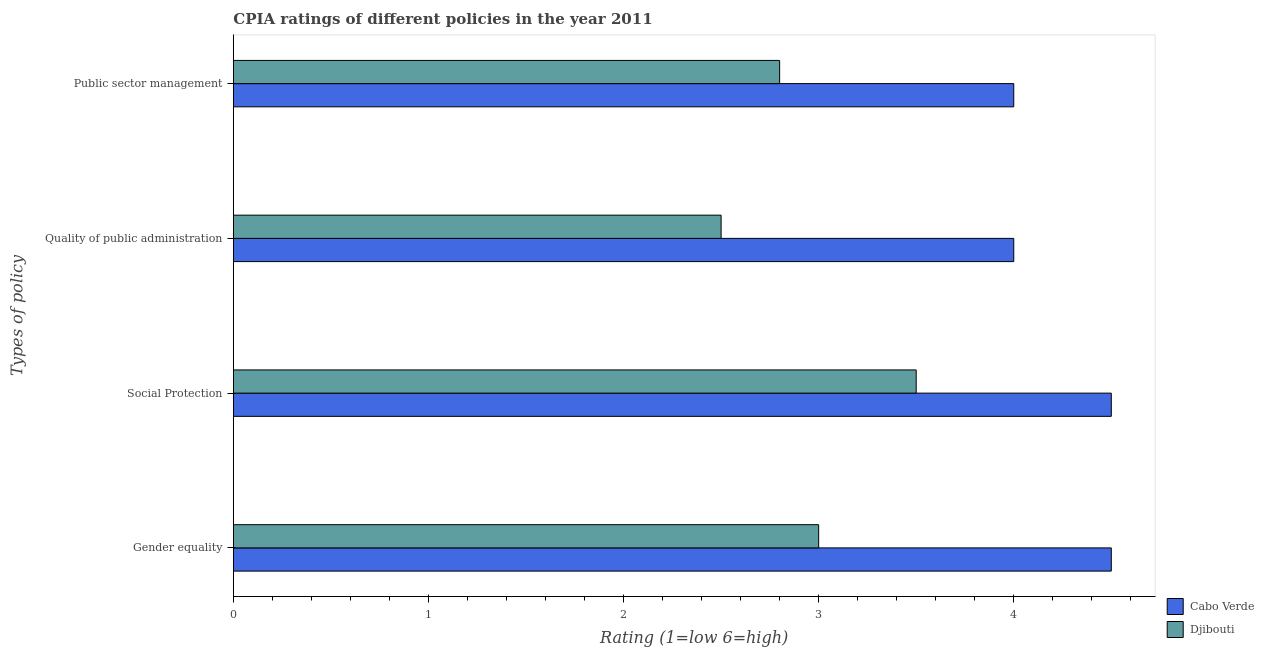How many different coloured bars are there?
Offer a terse response. 2. How many groups of bars are there?
Offer a very short reply. 4. How many bars are there on the 3rd tick from the top?
Your response must be concise. 2. What is the label of the 4th group of bars from the top?
Ensure brevity in your answer.  Gender equality. What is the cpia rating of quality of public administration in Cabo Verde?
Provide a succinct answer. 4. In which country was the cpia rating of quality of public administration maximum?
Your response must be concise. Cabo Verde. In which country was the cpia rating of gender equality minimum?
Offer a terse response. Djibouti. What is the total cpia rating of public sector management in the graph?
Provide a succinct answer. 6.8. What is the difference between the cpia rating of quality of public administration in Cabo Verde and that in Djibouti?
Provide a short and direct response. 1.5. What is the difference between the cpia rating of social protection in Cabo Verde and the cpia rating of gender equality in Djibouti?
Your answer should be compact. 1.5. What is the average cpia rating of quality of public administration per country?
Offer a very short reply. 3.25. What is the difference between the cpia rating of quality of public administration and cpia rating of public sector management in Djibouti?
Provide a short and direct response. -0.3. In how many countries, is the cpia rating of gender equality greater than 0.4 ?
Provide a short and direct response. 2. What is the ratio of the cpia rating of gender equality in Djibouti to that in Cabo Verde?
Keep it short and to the point. 0.67. What is the difference between the highest and the lowest cpia rating of gender equality?
Your answer should be very brief. 1.5. In how many countries, is the cpia rating of quality of public administration greater than the average cpia rating of quality of public administration taken over all countries?
Your response must be concise. 1. Is the sum of the cpia rating of gender equality in Cabo Verde and Djibouti greater than the maximum cpia rating of social protection across all countries?
Make the answer very short. Yes. Is it the case that in every country, the sum of the cpia rating of public sector management and cpia rating of gender equality is greater than the sum of cpia rating of social protection and cpia rating of quality of public administration?
Provide a succinct answer. No. What does the 2nd bar from the top in Public sector management represents?
Ensure brevity in your answer.  Cabo Verde. What does the 1st bar from the bottom in Gender equality represents?
Make the answer very short. Cabo Verde. Is it the case that in every country, the sum of the cpia rating of gender equality and cpia rating of social protection is greater than the cpia rating of quality of public administration?
Ensure brevity in your answer.  Yes. Does the graph contain any zero values?
Give a very brief answer. No. How are the legend labels stacked?
Provide a succinct answer. Vertical. What is the title of the graph?
Your response must be concise. CPIA ratings of different policies in the year 2011. What is the label or title of the X-axis?
Offer a terse response. Rating (1=low 6=high). What is the label or title of the Y-axis?
Your answer should be compact. Types of policy. What is the Rating (1=low 6=high) of Cabo Verde in Gender equality?
Offer a very short reply. 4.5. What is the Rating (1=low 6=high) of Cabo Verde in Social Protection?
Provide a succinct answer. 4.5. What is the Rating (1=low 6=high) in Djibouti in Social Protection?
Offer a terse response. 3.5. What is the Rating (1=low 6=high) in Cabo Verde in Quality of public administration?
Provide a short and direct response. 4. What is the Rating (1=low 6=high) of Djibouti in Quality of public administration?
Provide a short and direct response. 2.5. What is the Rating (1=low 6=high) of Cabo Verde in Public sector management?
Offer a terse response. 4. What is the Rating (1=low 6=high) of Djibouti in Public sector management?
Offer a terse response. 2.8. Across all Types of policy, what is the maximum Rating (1=low 6=high) in Djibouti?
Provide a succinct answer. 3.5. Across all Types of policy, what is the minimum Rating (1=low 6=high) of Cabo Verde?
Keep it short and to the point. 4. What is the total Rating (1=low 6=high) in Djibouti in the graph?
Your response must be concise. 11.8. What is the difference between the Rating (1=low 6=high) of Cabo Verde in Gender equality and that in Social Protection?
Keep it short and to the point. 0. What is the difference between the Rating (1=low 6=high) in Djibouti in Gender equality and that in Quality of public administration?
Your answer should be very brief. 0.5. What is the difference between the Rating (1=low 6=high) of Djibouti in Gender equality and that in Public sector management?
Keep it short and to the point. 0.2. What is the difference between the Rating (1=low 6=high) of Djibouti in Social Protection and that in Quality of public administration?
Keep it short and to the point. 1. What is the difference between the Rating (1=low 6=high) in Djibouti in Social Protection and that in Public sector management?
Offer a very short reply. 0.7. What is the difference between the Rating (1=low 6=high) of Djibouti in Quality of public administration and that in Public sector management?
Offer a terse response. -0.3. What is the difference between the Rating (1=low 6=high) of Cabo Verde in Gender equality and the Rating (1=low 6=high) of Djibouti in Social Protection?
Make the answer very short. 1. What is the difference between the Rating (1=low 6=high) in Cabo Verde in Gender equality and the Rating (1=low 6=high) in Djibouti in Quality of public administration?
Make the answer very short. 2. What is the difference between the Rating (1=low 6=high) in Cabo Verde in Social Protection and the Rating (1=low 6=high) in Djibouti in Quality of public administration?
Offer a terse response. 2. What is the difference between the Rating (1=low 6=high) in Cabo Verde in Quality of public administration and the Rating (1=low 6=high) in Djibouti in Public sector management?
Give a very brief answer. 1.2. What is the average Rating (1=low 6=high) in Cabo Verde per Types of policy?
Ensure brevity in your answer.  4.25. What is the average Rating (1=low 6=high) of Djibouti per Types of policy?
Your response must be concise. 2.95. What is the difference between the Rating (1=low 6=high) of Cabo Verde and Rating (1=low 6=high) of Djibouti in Gender equality?
Make the answer very short. 1.5. What is the ratio of the Rating (1=low 6=high) of Cabo Verde in Gender equality to that in Social Protection?
Offer a terse response. 1. What is the ratio of the Rating (1=low 6=high) of Cabo Verde in Gender equality to that in Public sector management?
Your answer should be very brief. 1.12. What is the ratio of the Rating (1=low 6=high) of Djibouti in Gender equality to that in Public sector management?
Your response must be concise. 1.07. What is the ratio of the Rating (1=low 6=high) of Cabo Verde in Social Protection to that in Quality of public administration?
Give a very brief answer. 1.12. What is the ratio of the Rating (1=low 6=high) of Djibouti in Social Protection to that in Quality of public administration?
Keep it short and to the point. 1.4. What is the ratio of the Rating (1=low 6=high) in Cabo Verde in Social Protection to that in Public sector management?
Your answer should be very brief. 1.12. What is the ratio of the Rating (1=low 6=high) in Cabo Verde in Quality of public administration to that in Public sector management?
Keep it short and to the point. 1. What is the ratio of the Rating (1=low 6=high) of Djibouti in Quality of public administration to that in Public sector management?
Keep it short and to the point. 0.89. What is the difference between the highest and the second highest Rating (1=low 6=high) of Djibouti?
Provide a short and direct response. 0.5. What is the difference between the highest and the lowest Rating (1=low 6=high) in Cabo Verde?
Your answer should be compact. 0.5. 